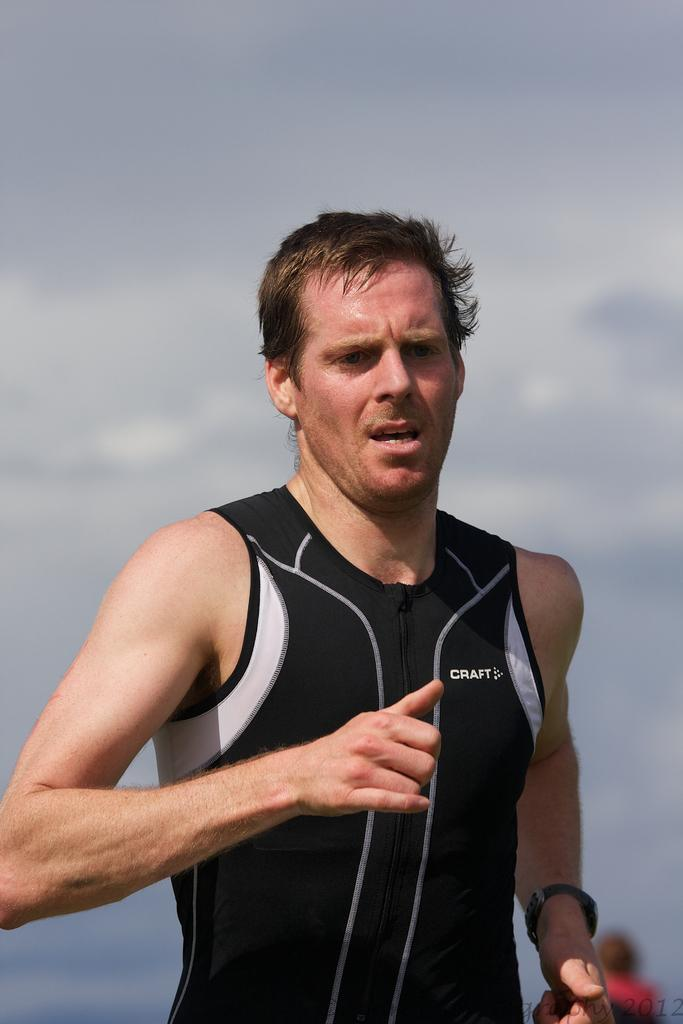<image>
Create a compact narrative representing the image presented. a man with some clothing that says craft on it 